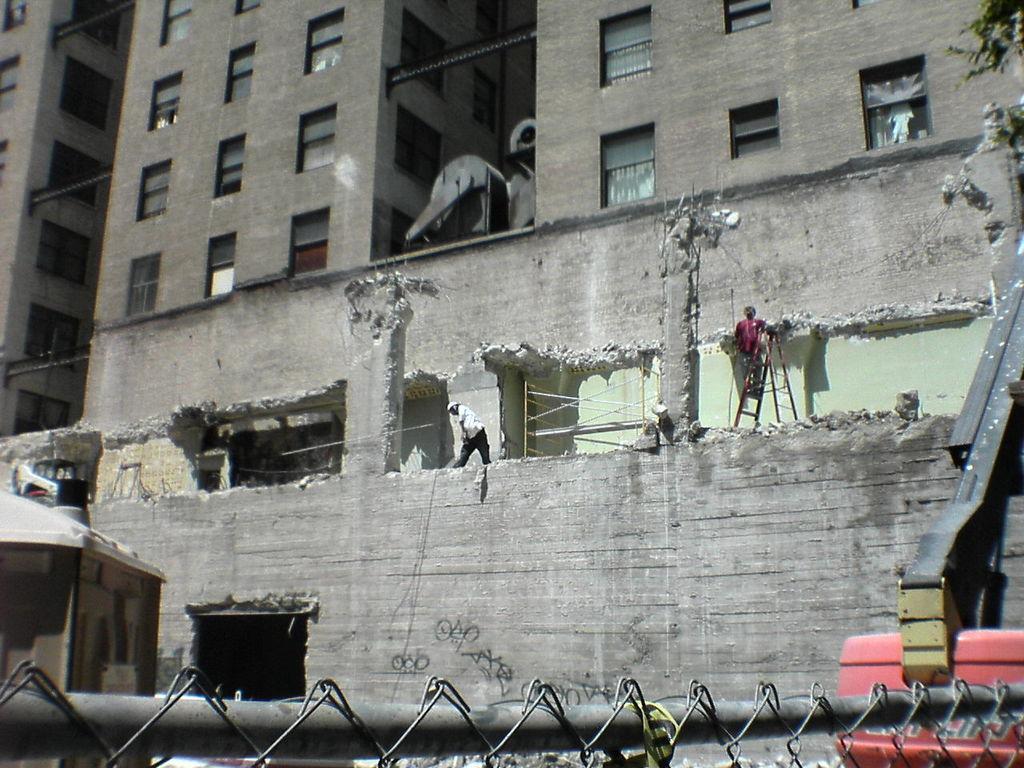Can you describe this image briefly? In the center of the image we can see persons in a building. At the bottom of the image there is a vehicle, fencing. In the background there is a building under excavation. 